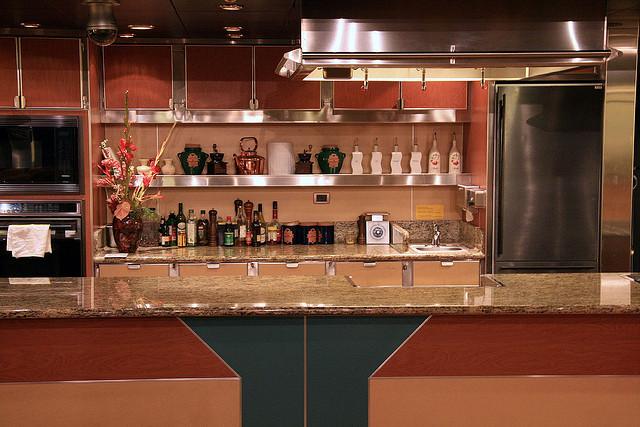Is this picture in a barn?
Keep it brief. No. What type of top is this?
Answer briefly. Granite. What room is this?
Answer briefly. Kitchen. 